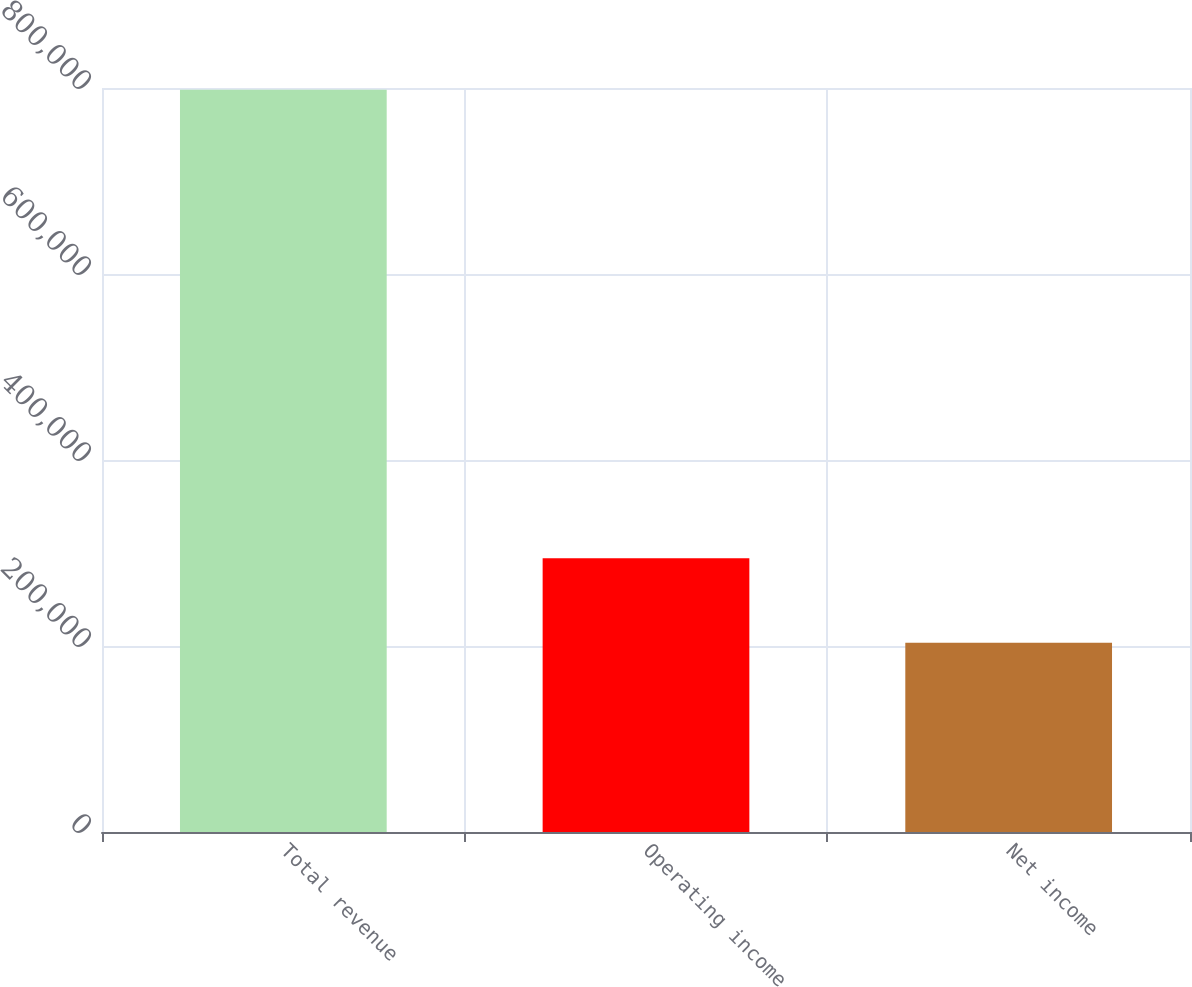Convert chart to OTSL. <chart><loc_0><loc_0><loc_500><loc_500><bar_chart><fcel>Total revenue<fcel>Operating income<fcel>Net income<nl><fcel>798018<fcel>294253<fcel>203483<nl></chart> 